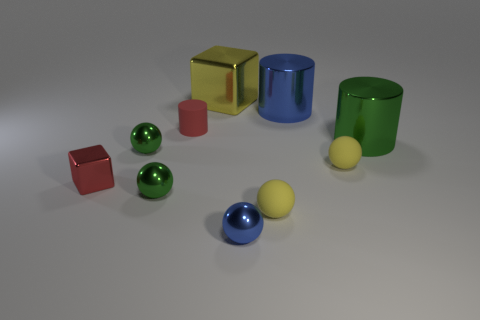How many cubes are tiny yellow matte things or big green shiny things?
Your answer should be compact. 0. What material is the tiny cylinder that is the same color as the tiny block?
Give a very brief answer. Rubber. How many small shiny objects are the same shape as the big blue metallic thing?
Ensure brevity in your answer.  0. Is the number of large shiny cylinders that are behind the big green cylinder greater than the number of green objects that are left of the small blue metallic thing?
Your response must be concise. No. Do the small matte ball in front of the small red metal object and the big block have the same color?
Your answer should be compact. Yes. How big is the blue metallic cylinder?
Offer a very short reply. Large. What material is the green cylinder that is the same size as the yellow shiny block?
Make the answer very short. Metal. The large metal cylinder that is in front of the big blue cylinder is what color?
Provide a succinct answer. Green. How many big yellow blocks are there?
Your answer should be compact. 1. Is there a big yellow metallic object on the right side of the big cylinder that is on the left side of the cylinder that is in front of the tiny red rubber object?
Provide a short and direct response. No. 